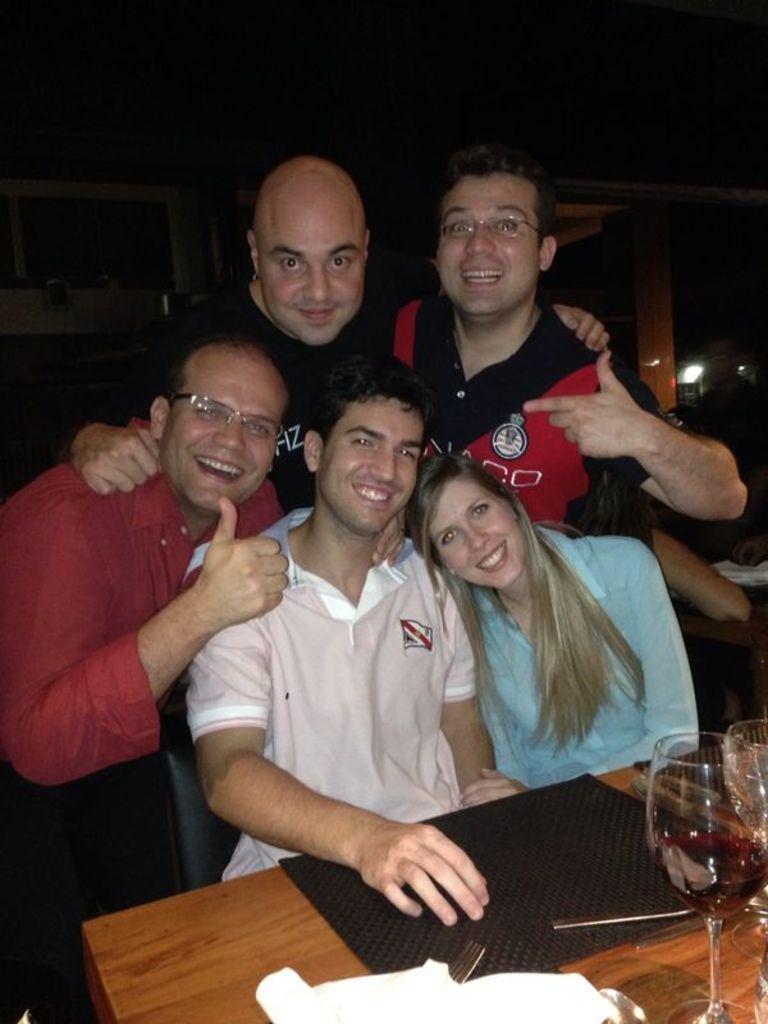In one or two sentences, can you explain what this image depicts? As we can see in the image there are few people sitting and standing and there is a table. On table there is a mat and glasses. 